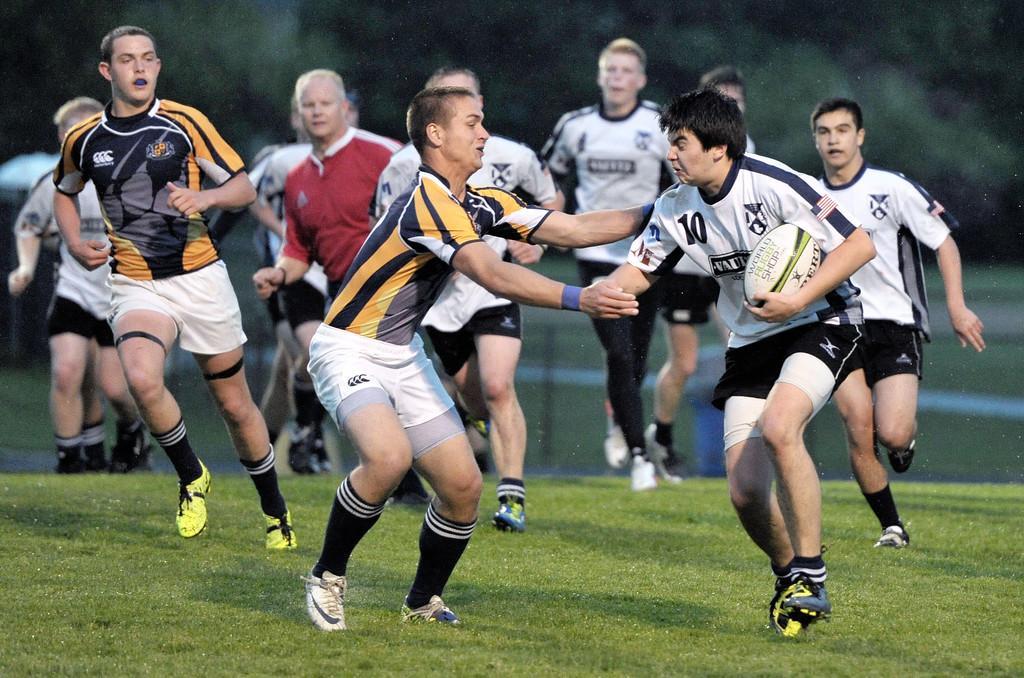Can you describe this image briefly? In this image we can see people playing a game. On the left we can see a ball in the person's hand. At the bottom there is grass. In the background there are trees. 